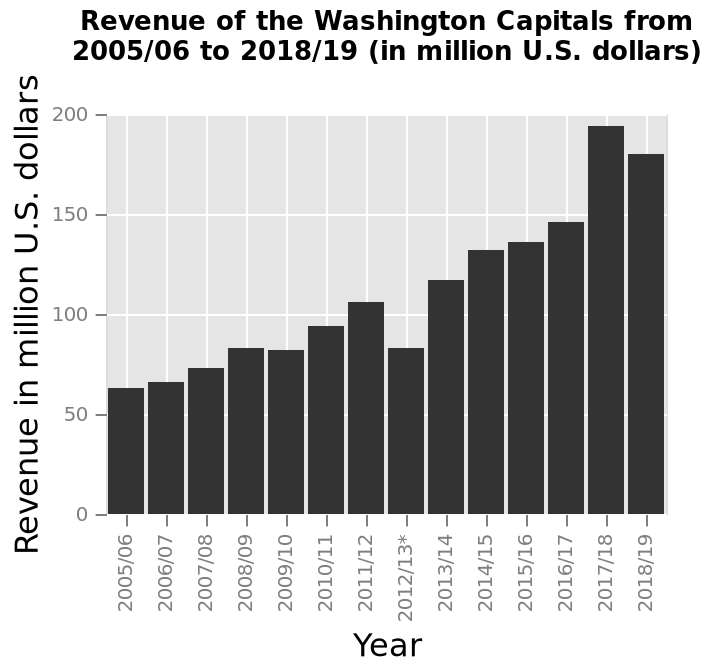<image>
please describe the details of the chart Revenue of the Washington Capitals from 2005/06 to 2018/19 (in million U.S. dollars) is a bar chart. A categorical scale starting at 2005/06 and ending at 2018/19 can be found along the x-axis, marked Year. There is a linear scale from 0 to 200 along the y-axis, marked Revenue in million U.S. dollars. Which year had the highest level of revenue?  The year 2017/18 had the highest level of revenue. 